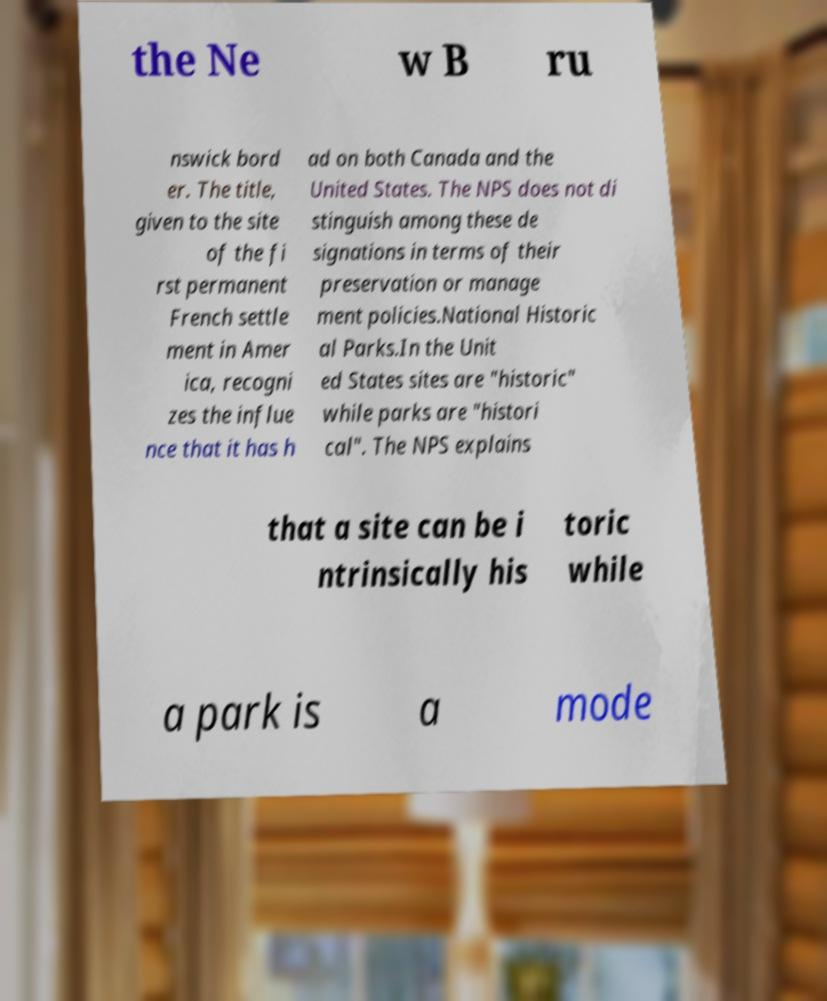There's text embedded in this image that I need extracted. Can you transcribe it verbatim? the Ne w B ru nswick bord er. The title, given to the site of the fi rst permanent French settle ment in Amer ica, recogni zes the influe nce that it has h ad on both Canada and the United States. The NPS does not di stinguish among these de signations in terms of their preservation or manage ment policies.National Historic al Parks.In the Unit ed States sites are "historic" while parks are "histori cal". The NPS explains that a site can be i ntrinsically his toric while a park is a mode 